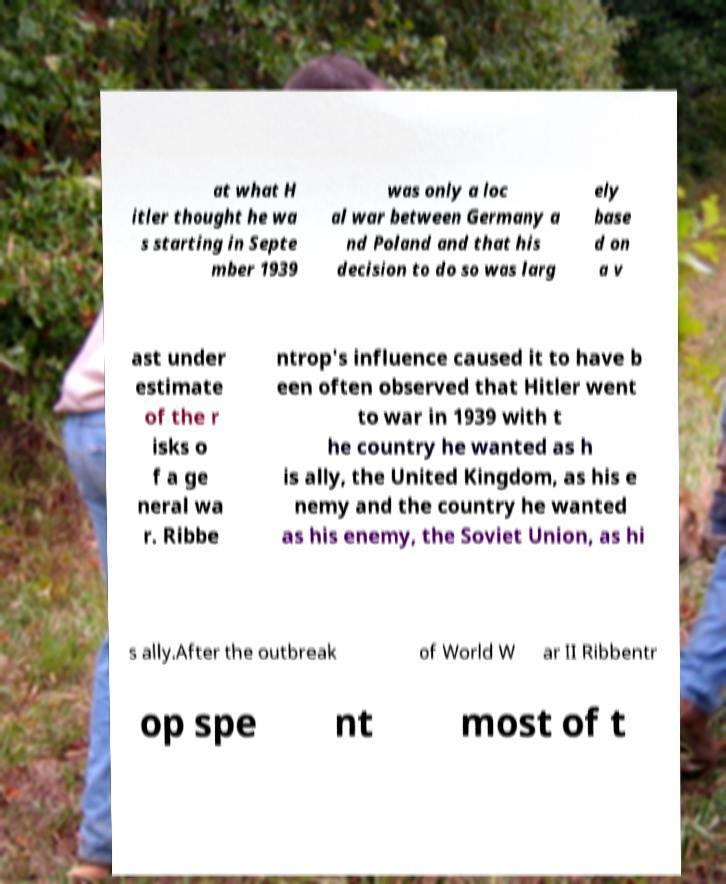Can you read and provide the text displayed in the image?This photo seems to have some interesting text. Can you extract and type it out for me? at what H itler thought he wa s starting in Septe mber 1939 was only a loc al war between Germany a nd Poland and that his decision to do so was larg ely base d on a v ast under estimate of the r isks o f a ge neral wa r. Ribbe ntrop's influence caused it to have b een often observed that Hitler went to war in 1939 with t he country he wanted as h is ally, the United Kingdom, as his e nemy and the country he wanted as his enemy, the Soviet Union, as hi s ally.After the outbreak of World W ar II Ribbentr op spe nt most of t 